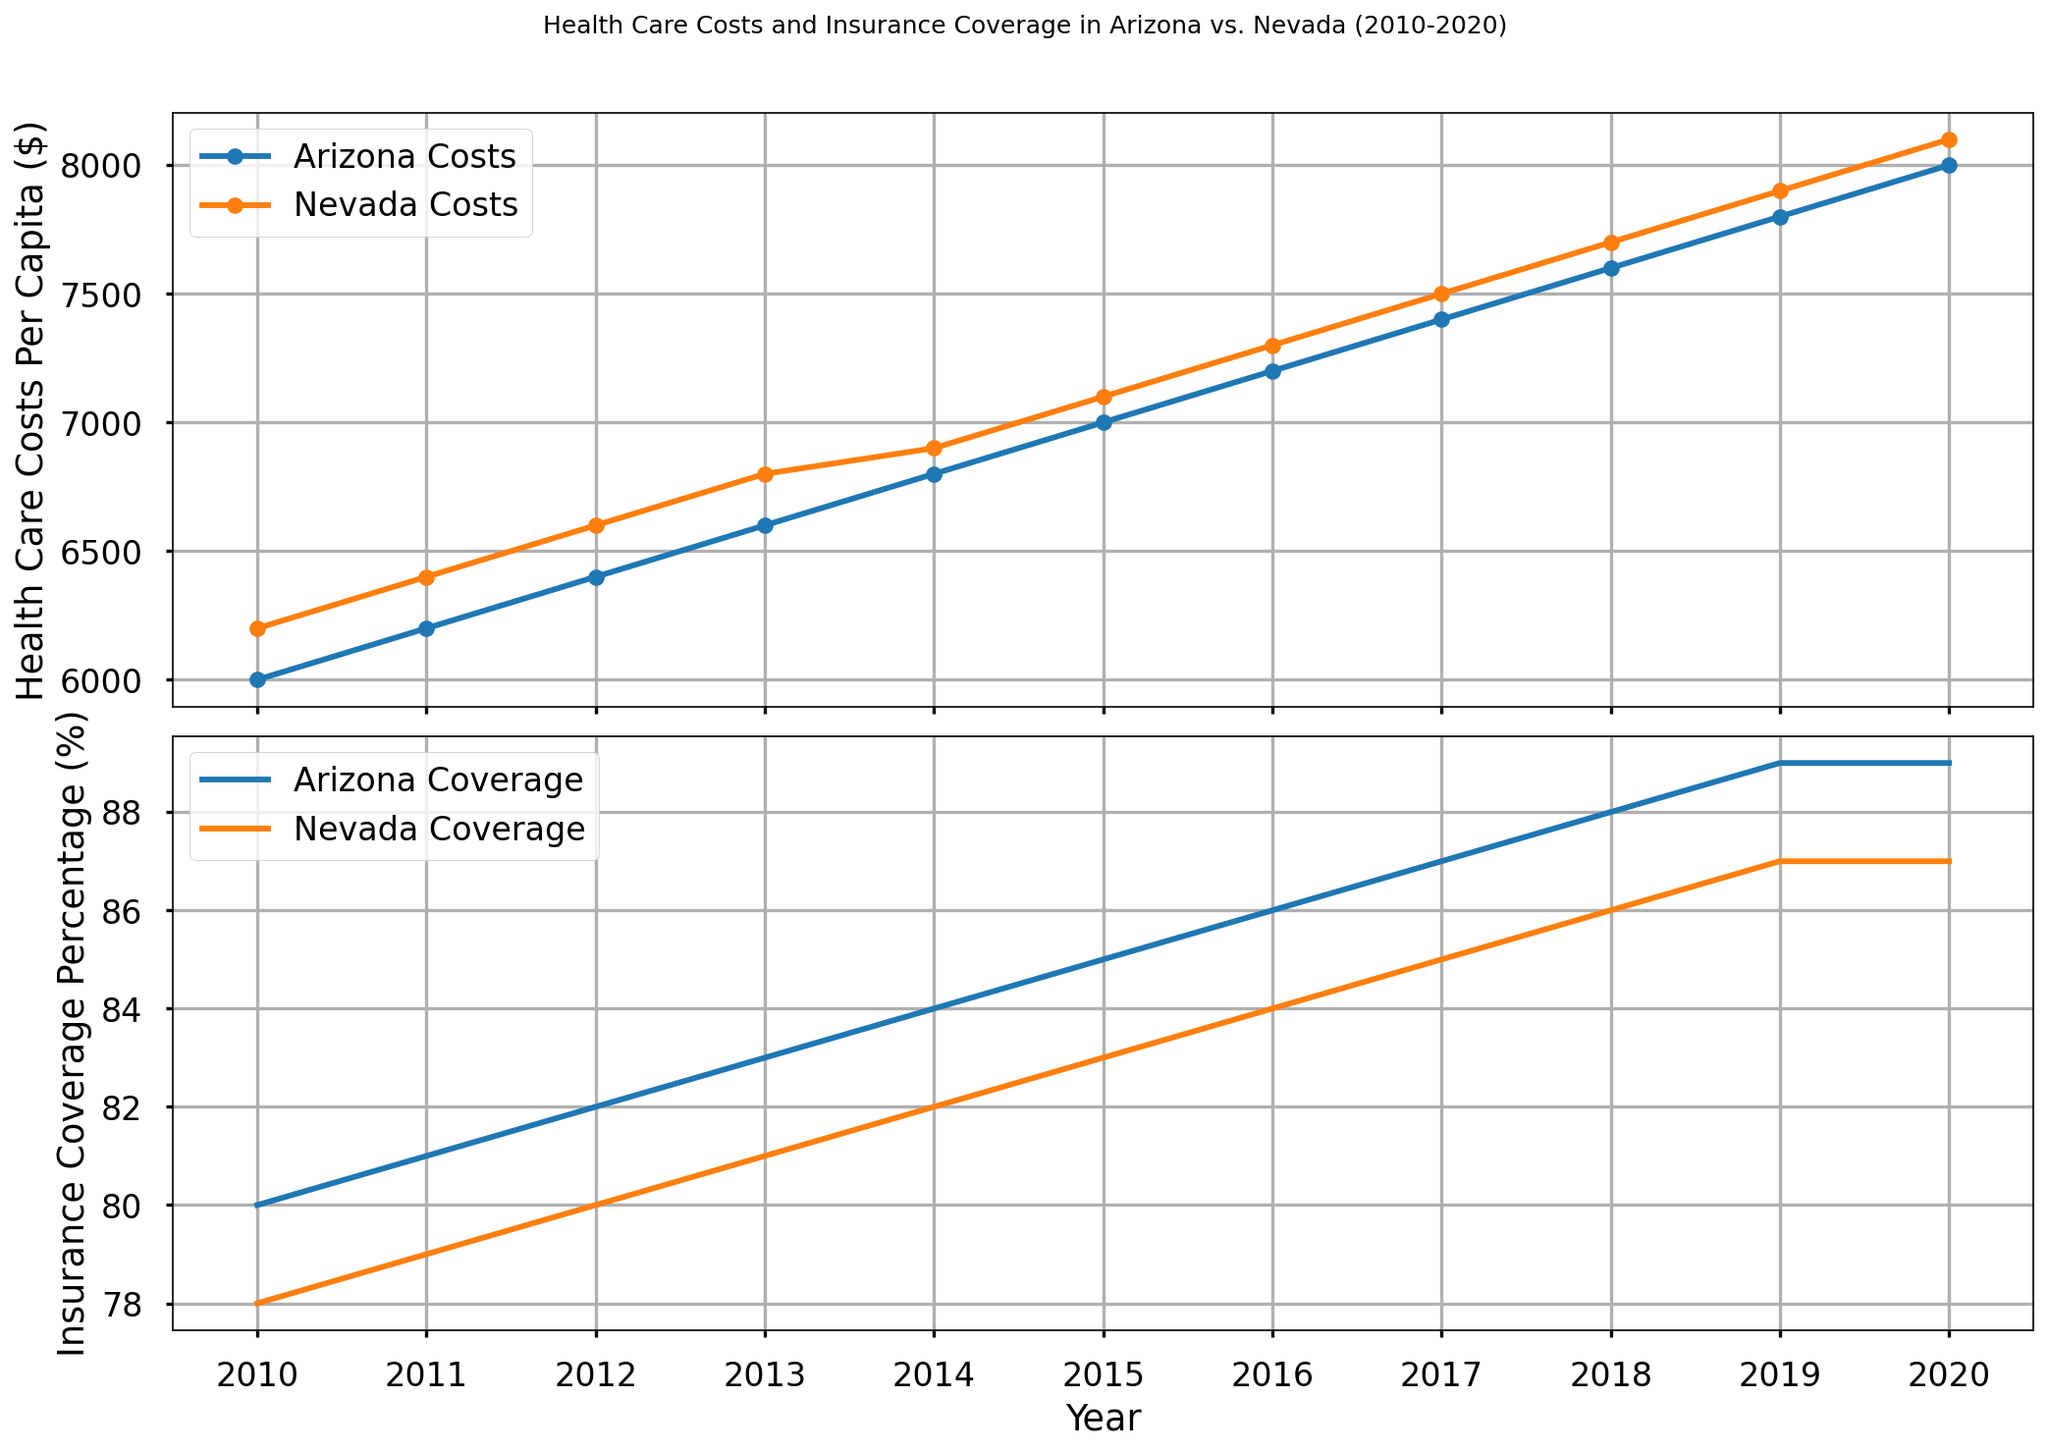What's the difference in Health Care Costs Per Capita between Arizona and Nevada in 2010? In 2010, Arizona's health care costs were $6000, and Nevada's were $6200. The difference is $6200 - $6000 = $200.
Answer: $200 How did Insurance Coverage Percentage change in Arizona from 2010 to 2020? In 2010, Arizona's insurance coverage was 80%. By 2020, it was 89%. The change is 89% - 80% = 9%.
Answer: 9% In which year did Nevada's Health Care Costs Per Capita first exceed $7000? By examining the plot, Nevada's costs exceeded $7000 in 2014 when they reached $7100.
Answer: 2014 Which state had a higher Insurance Coverage Percentage in 2015, and by how much? In 2015, Arizona had 85% coverage, and Nevada had 83% coverage. Arizona's coverage was higher by 85% - 83% = 2%.
Answer: Arizona, 2% What was the percentage increase in Health Care Costs Per Capita for Arizona from 2010 to 2020? In 2010, Arizona's costs were $6000 and $8000 in 2020. The increase is ($8000 - $6000) / $6000 * 100% = 33.33%.
Answer: 33.33% Compare the growth trends of Insurance Coverage in Arizona and Nevada from 2010 to 2020. For Arizona, insurance coverage increased from 80% to 89%, a 9% increase. For Nevada, it increased from 78% to 87%, also a 9% increase. Both states have equal growth in their coverage percentages over the period.
Answer: Equal, 9% What is the average Health Care Costs Per Capita in Arizona over the decade? The average is the sum of the annual health care costs divided by the number of years. Sum of values = $6000 + $6200 + $6400 + $6600 + $6800 + $7000 + $7200 + $7400 + $7600 + $7800 + $8000 = $70000. Average = $70000 / 10 = $7000.
Answer: $7000 